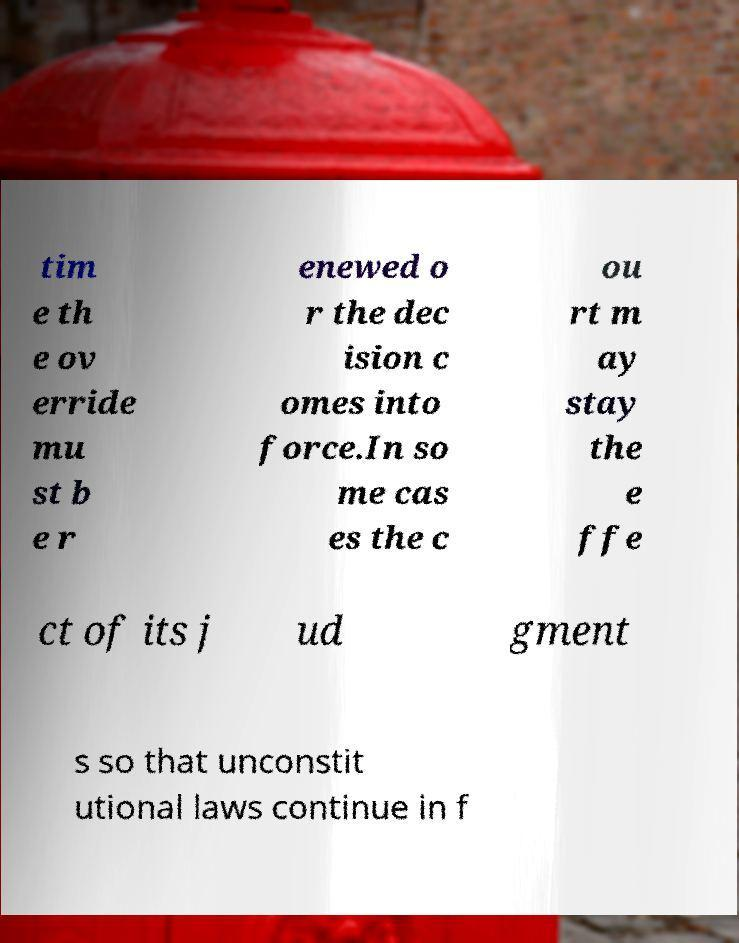Can you accurately transcribe the text from the provided image for me? tim e th e ov erride mu st b e r enewed o r the dec ision c omes into force.In so me cas es the c ou rt m ay stay the e ffe ct of its j ud gment s so that unconstit utional laws continue in f 